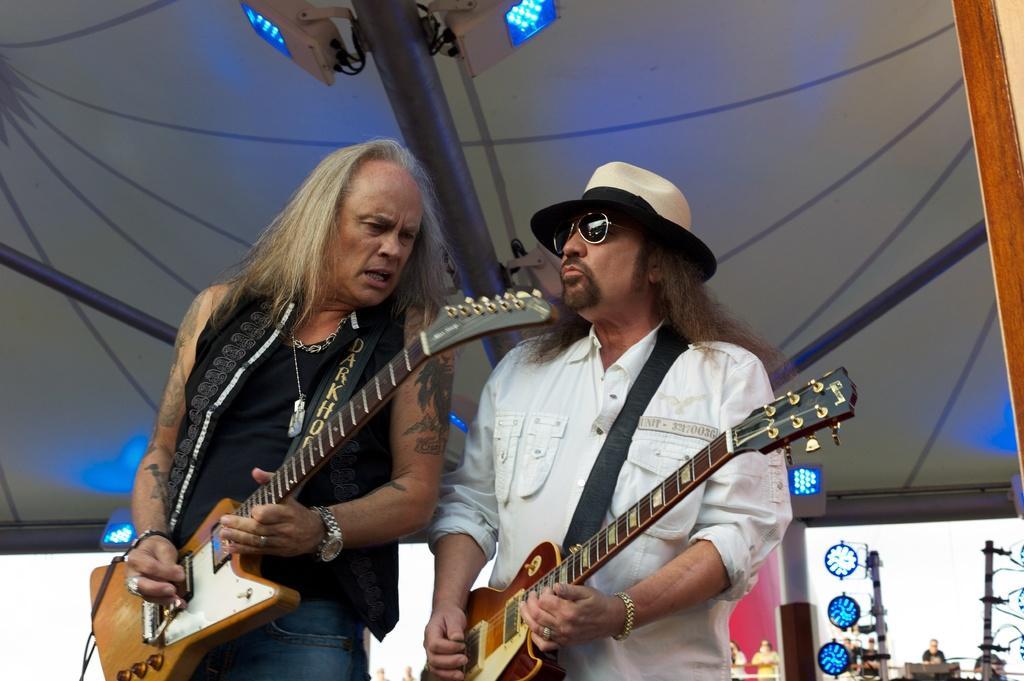Can you describe this image briefly? As we can see in the image there is a umbrella, two people standing and holding guitars, the man who is standing on the right side is wearing white color shirt and goggles. 